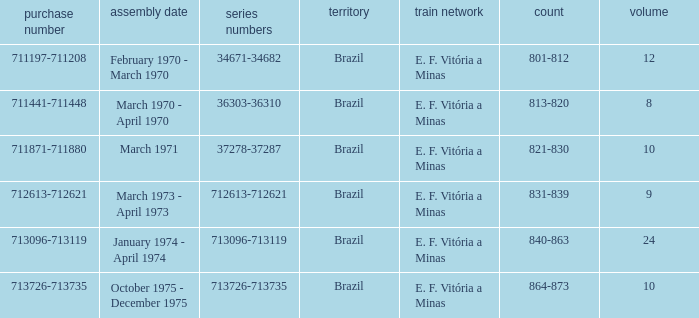The order number 713726-713735 has what serial number? 713726-713735. Write the full table. {'header': ['purchase number', 'assembly date', 'series numbers', 'territory', 'train network', 'count', 'volume'], 'rows': [['711197-711208', 'February 1970 - March 1970', '34671-34682', 'Brazil', 'E. F. Vitória a Minas', '801-812', '12'], ['711441-711448', 'March 1970 - April 1970', '36303-36310', 'Brazil', 'E. F. Vitória a Minas', '813-820', '8'], ['711871-711880', 'March 1971', '37278-37287', 'Brazil', 'E. F. Vitória a Minas', '821-830', '10'], ['712613-712621', 'March 1973 - April 1973', '712613-712621', 'Brazil', 'E. F. Vitória a Minas', '831-839', '9'], ['713096-713119', 'January 1974 - April 1974', '713096-713119', 'Brazil', 'E. F. Vitória a Minas', '840-863', '24'], ['713726-713735', 'October 1975 - December 1975', '713726-713735', 'Brazil', 'E. F. Vitória a Minas', '864-873', '10']]} 